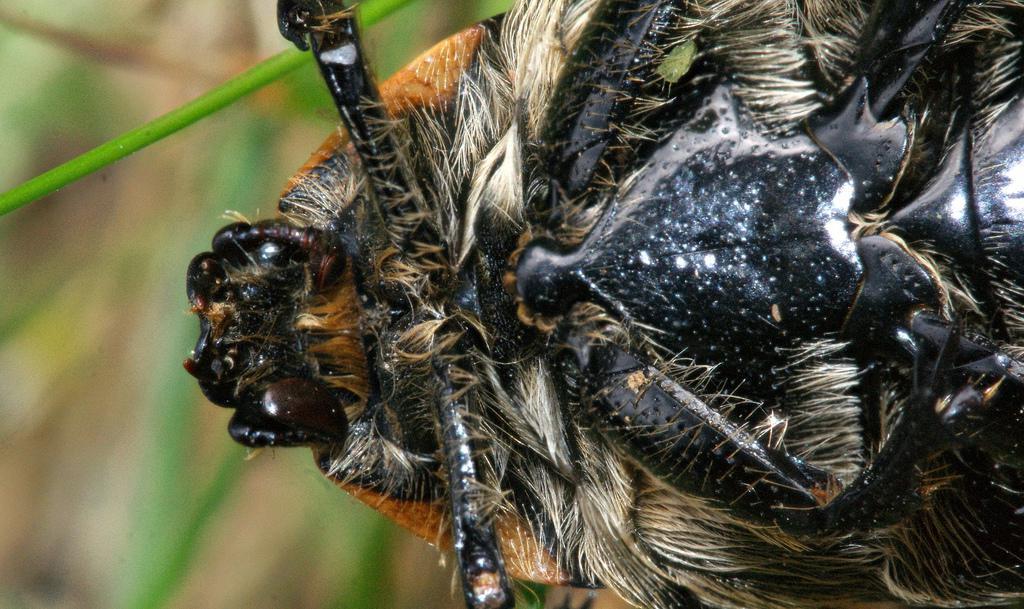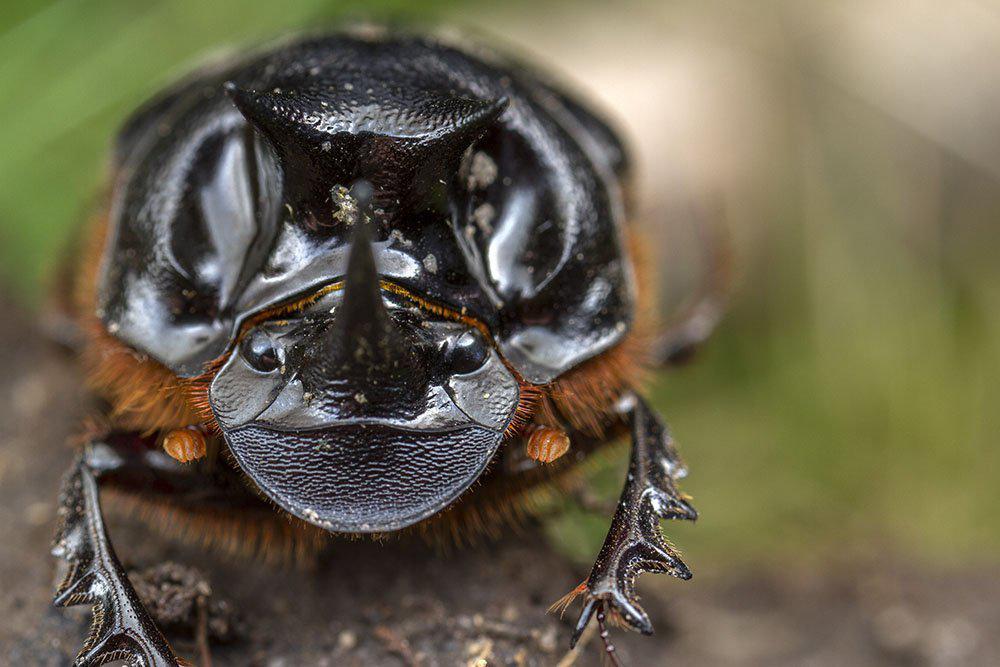The first image is the image on the left, the second image is the image on the right. Assess this claim about the two images: "The beetle on the left is near green grass.". Correct or not? Answer yes or no. Yes. The first image is the image on the left, the second image is the image on the right. Assess this claim about the two images: "One image shows the underside of a beetle instead of the top side.". Correct or not? Answer yes or no. Yes. 